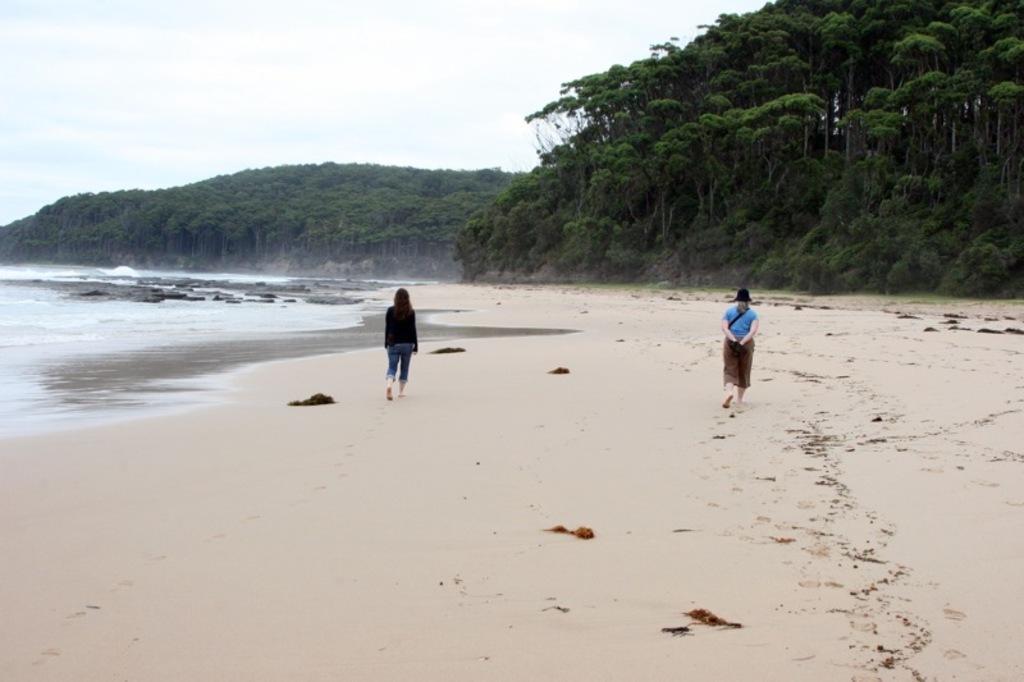Please provide a concise description of this image. In this image we can see two persons walking on the seashore and there are some rocks and we can see some trees and at the top we can see the sky. 